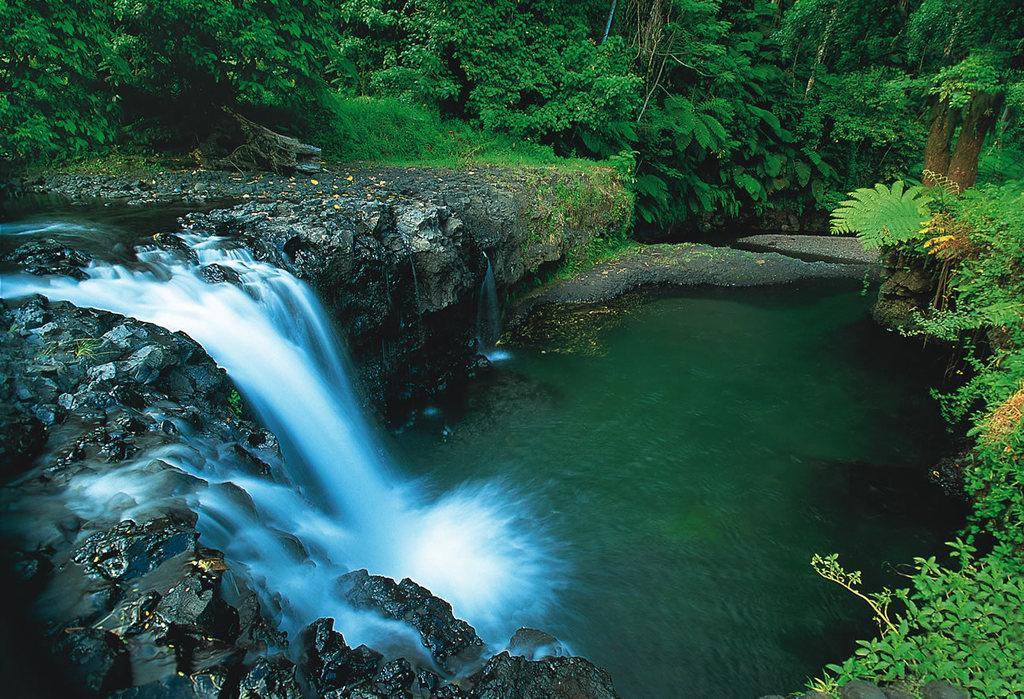In one or two sentences, can you explain what this image depicts? In this image I can see a waterfall on the left side and on the right side I can see water. In the background and on the right side of this image I can see number of trees. 